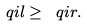<formula> <loc_0><loc_0><loc_500><loc_500>\ q i { l } \geq \ q i { r } .</formula> 